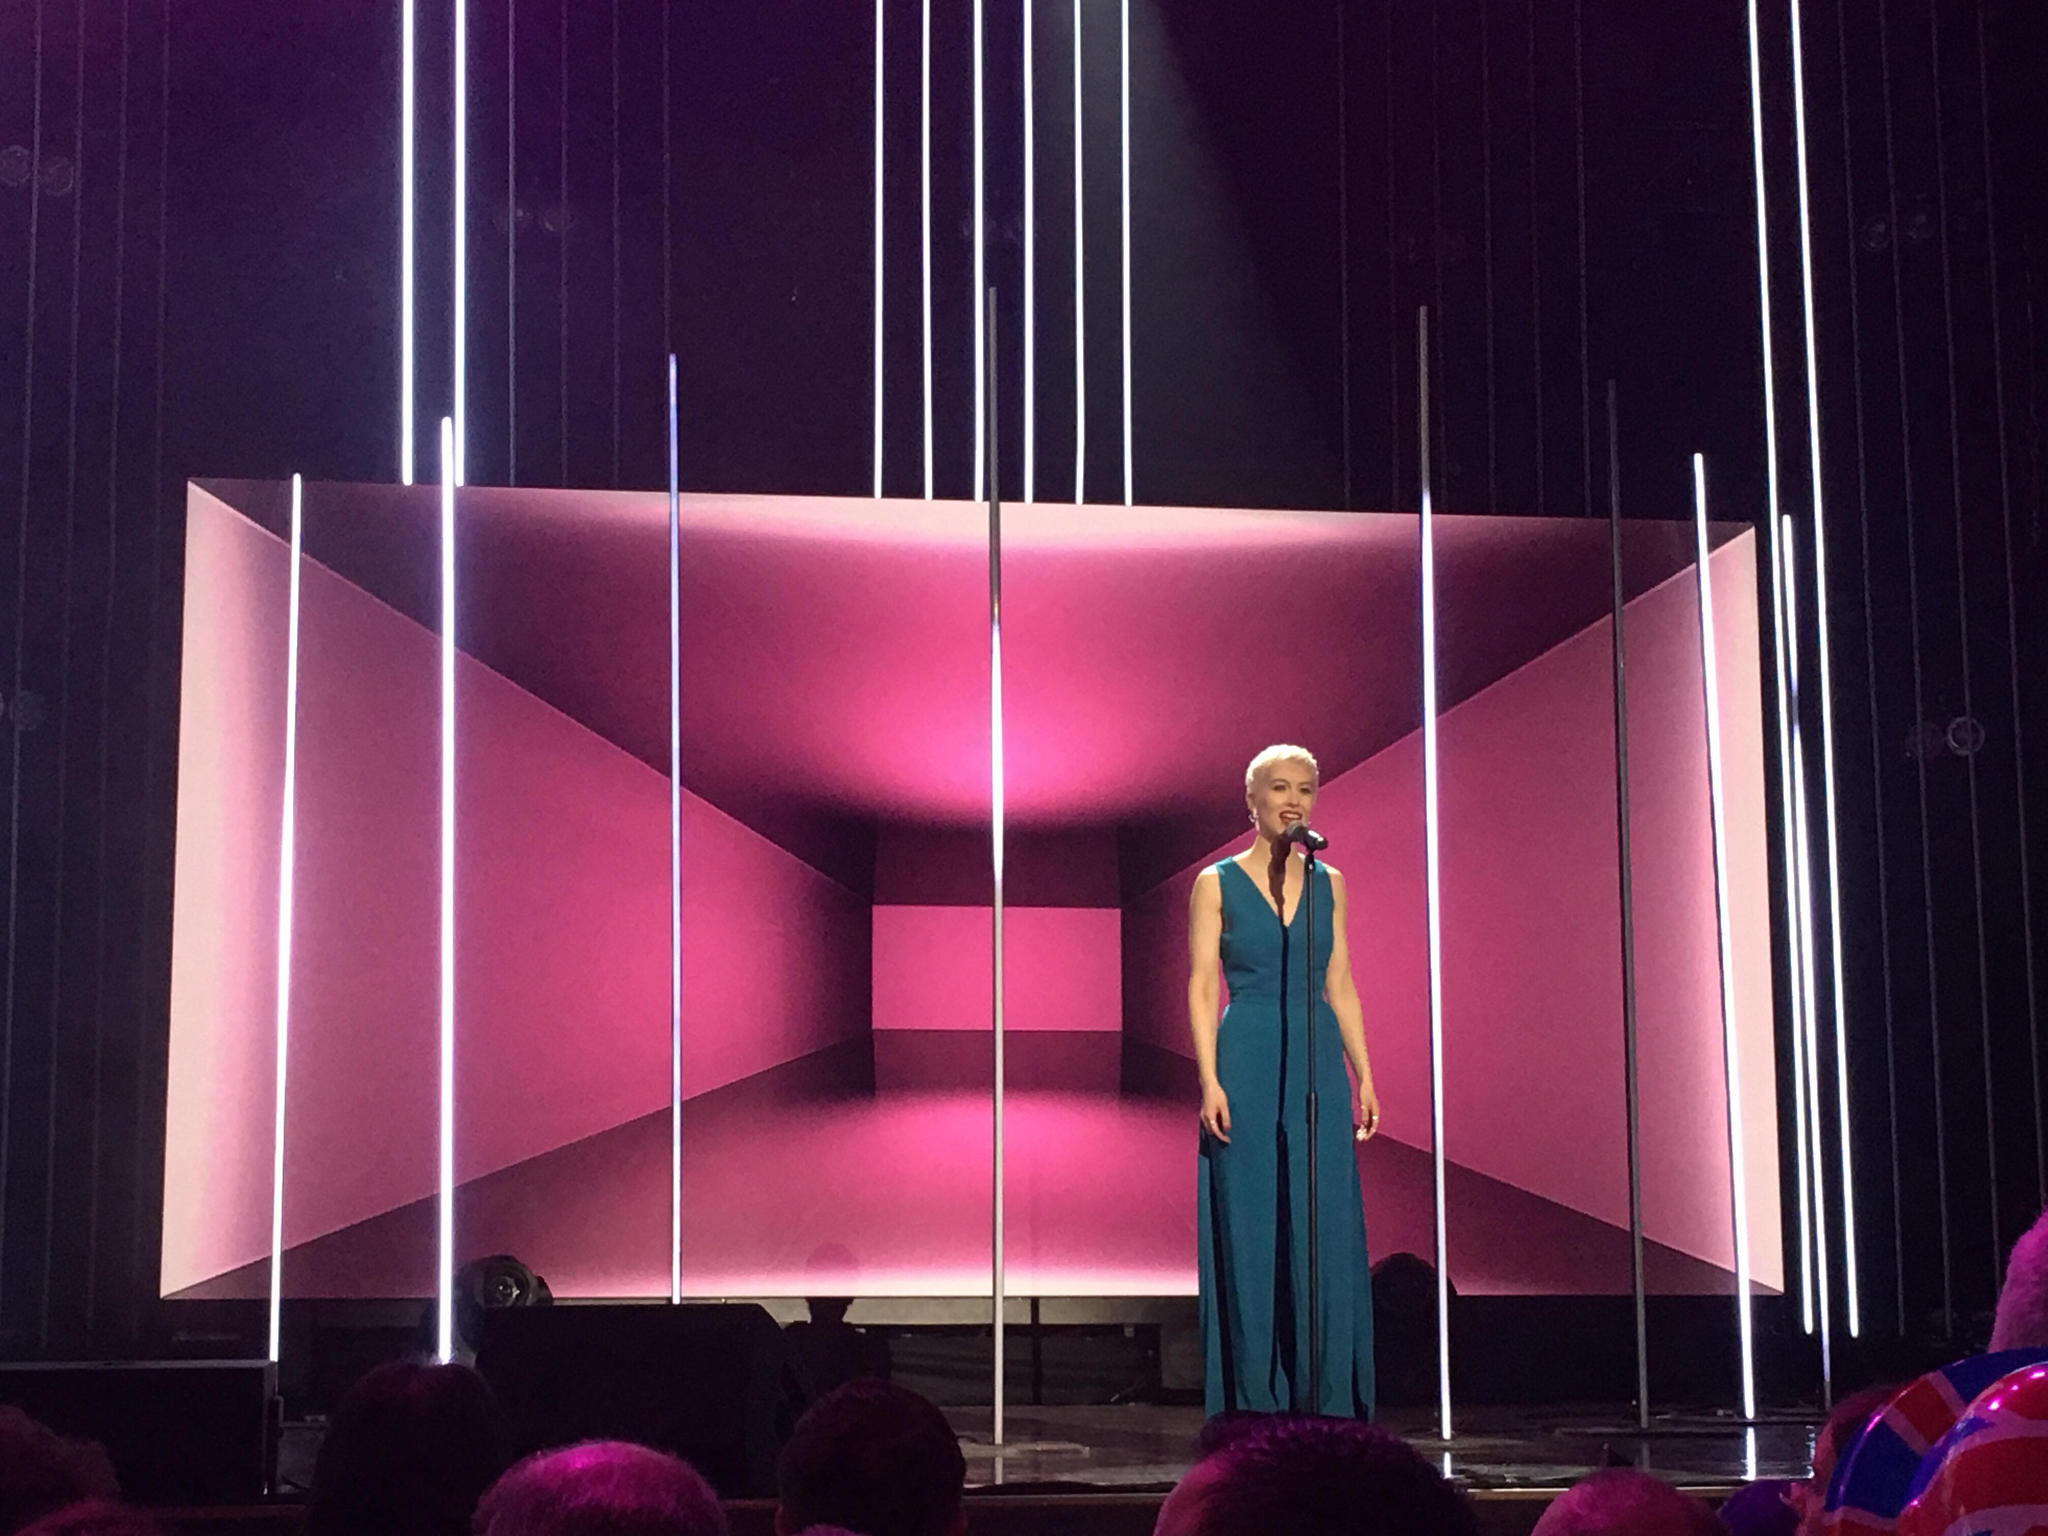Considering the stage design and lighting, what could be the theme or mood that the performance is trying to convey? The stage design, with its geometric precision and vertical beams of white light, exudes a feeling of modernity and cutting-edge sophistication. The backdrop's rich pink and purple hues inject warmth and a sense of depth, possibly hinting at themes of passion or the power of creativity. Moreover, the symmetry and meticulous arrangement of the setting may suggest a performance that is emotionally charged and yet highly controlled, offering an audience an experience that balances raw sentiment with a polished, futuristic aesthetic. 